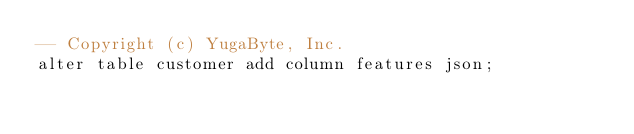<code> <loc_0><loc_0><loc_500><loc_500><_SQL_>-- Copyright (c) YugaByte, Inc.
alter table customer add column features json;
</code> 